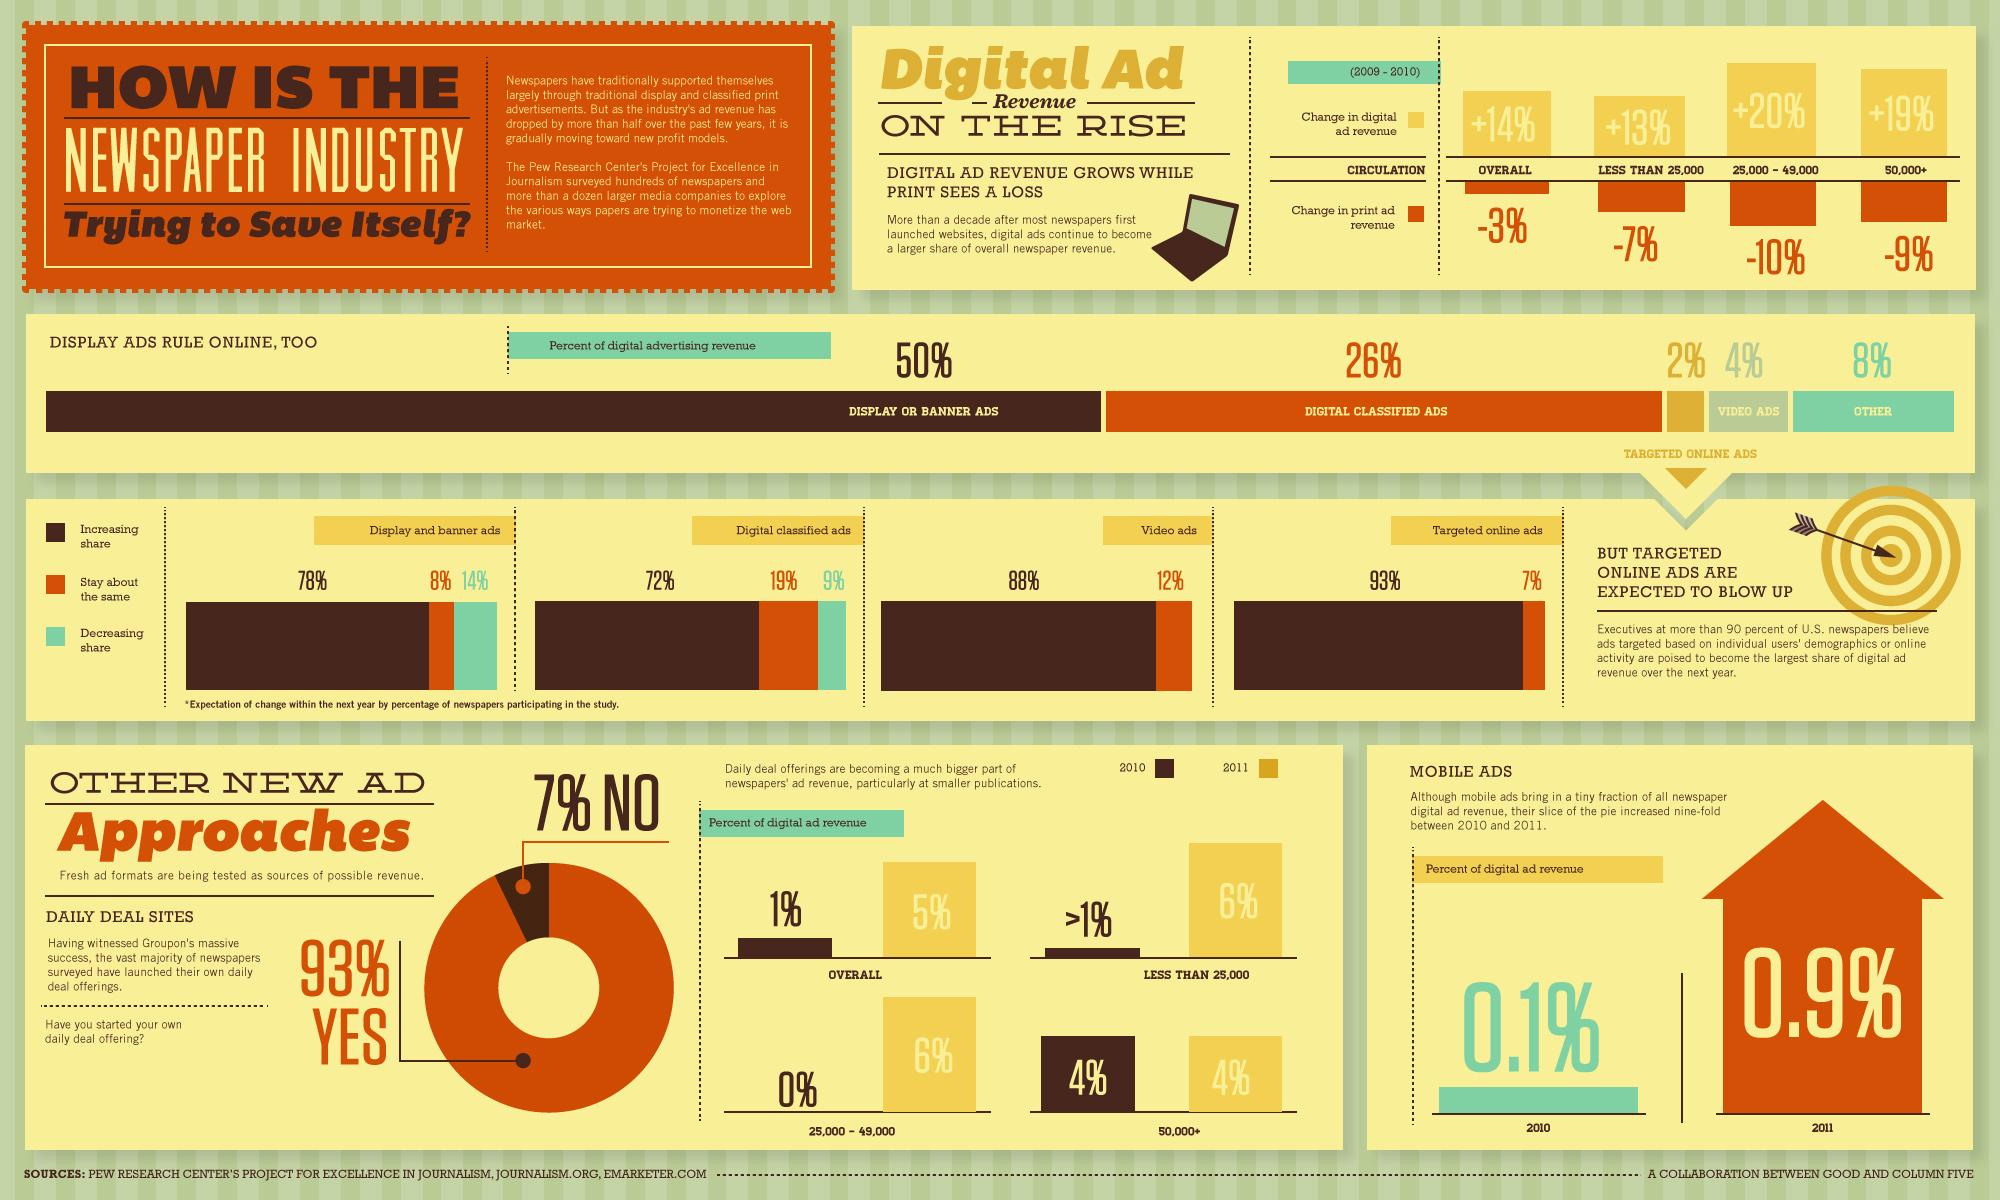List a handful of essential elements in this visual. According to the study, a 9% decrease in the share of digital classified ads is expected within the next year. According to recent statistics, video ads contribute only 4% of digital advertising revenue. Display or banner ads contribute the major part of revenue in the online newspaper industry. In 2010, digital ad revenue accounted for only 1% of the total advertising revenue generated by the music industry. The study predicts that the share of display and banner ads will increase by 78% within the next year. 